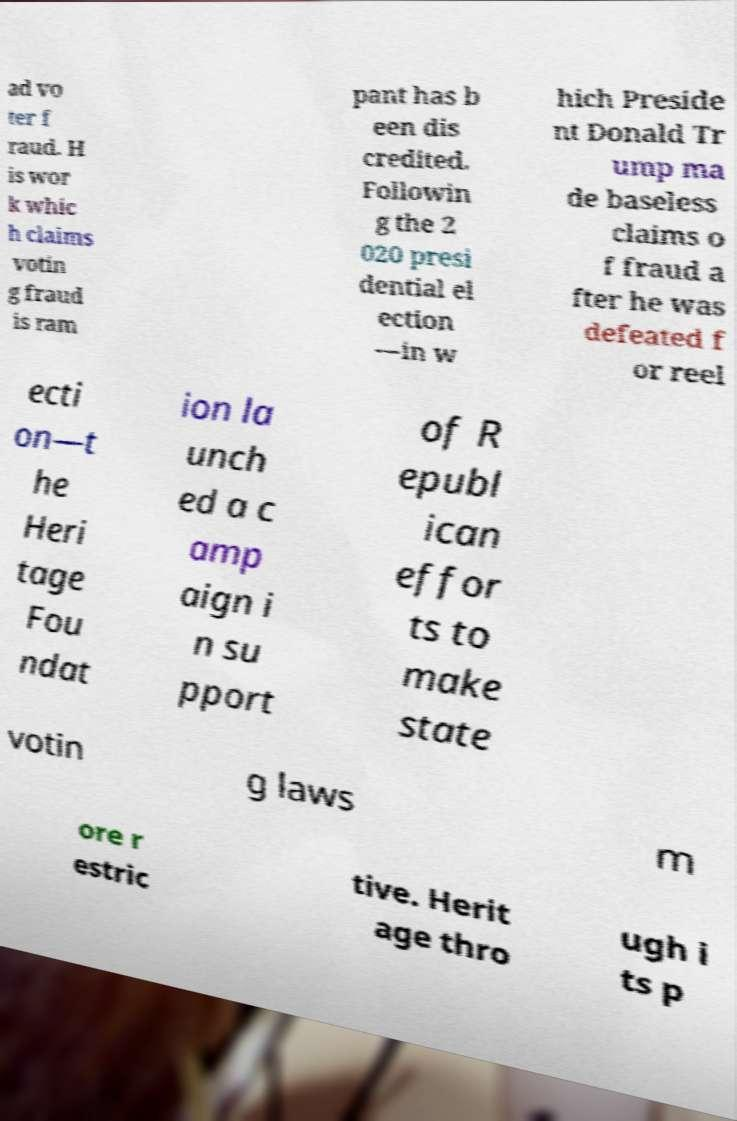Please identify and transcribe the text found in this image. ad vo ter f raud. H is wor k whic h claims votin g fraud is ram pant has b een dis credited. Followin g the 2 020 presi dential el ection —in w hich Preside nt Donald Tr ump ma de baseless claims o f fraud a fter he was defeated f or reel ecti on—t he Heri tage Fou ndat ion la unch ed a c amp aign i n su pport of R epubl ican effor ts to make state votin g laws m ore r estric tive. Herit age thro ugh i ts p 